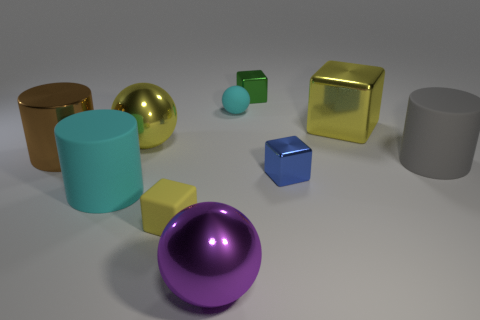Subtract all large brown shiny cylinders. How many cylinders are left? 2 Subtract all brown cylinders. How many cylinders are left? 2 Subtract all cylinders. How many objects are left? 7 Subtract 2 cylinders. How many cylinders are left? 1 Add 3 tiny green spheres. How many tiny green spheres exist? 3 Subtract 1 yellow spheres. How many objects are left? 9 Subtract all red spheres. Subtract all red blocks. How many spheres are left? 3 Subtract all red cylinders. How many purple blocks are left? 0 Subtract all tiny blocks. Subtract all big brown metallic things. How many objects are left? 6 Add 5 tiny metallic cubes. How many tiny metallic cubes are left? 7 